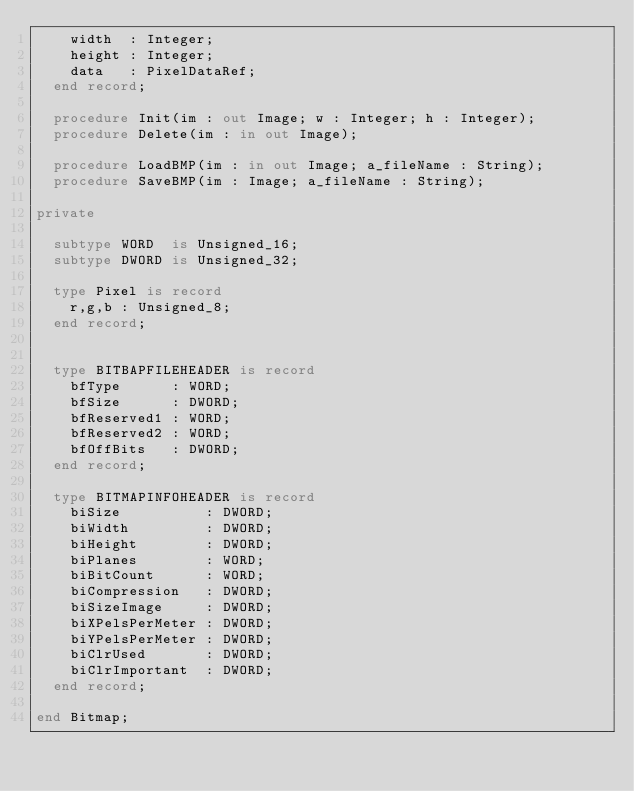Convert code to text. <code><loc_0><loc_0><loc_500><loc_500><_Ada_>    width  : Integer;
    height : Integer;
    data   : PixelDataRef;
  end record;

  procedure Init(im : out Image; w : Integer; h : Integer);
  procedure Delete(im : in out Image);

  procedure LoadBMP(im : in out Image; a_fileName : String);
  procedure SaveBMP(im : Image; a_fileName : String);

private

  subtype WORD  is Unsigned_16;
  subtype DWORD is Unsigned_32;

  type Pixel is record
    r,g,b : Unsigned_8;
  end record;


  type BITBAPFILEHEADER is record
    bfType      : WORD;
    bfSize      : DWORD;
    bfReserved1 : WORD;
    bfReserved2 : WORD;
    bfOffBits   : DWORD;
  end record;

  type BITMAPINFOHEADER is record
    biSize          : DWORD;
    biWidth         : DWORD;
    biHeight        : DWORD;
    biPlanes        : WORD;
    biBitCount      : WORD;
    biCompression   : DWORD;
    biSizeImage     : DWORD;
    biXPelsPerMeter : DWORD;
    biYPelsPerMeter : DWORD;
    biClrUsed       : DWORD;
    biClrImportant  : DWORD;
  end record;

end Bitmap;
</code> 